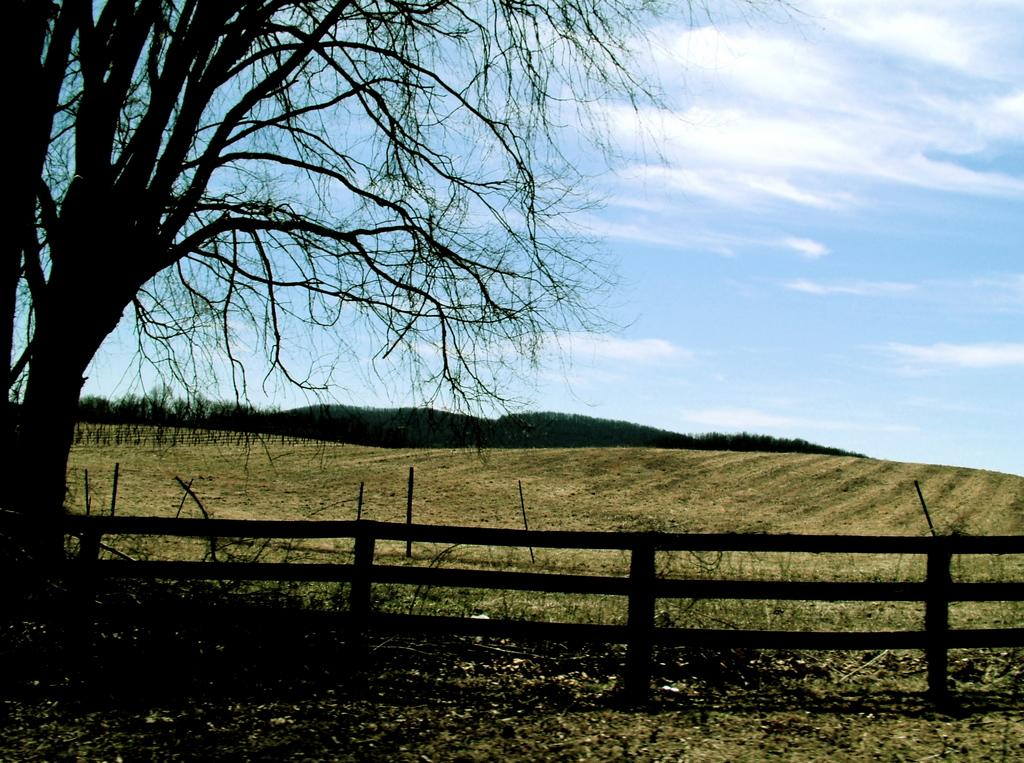What is the setting of the image? The image has an outside view. What can be seen in the foreground of the image? There is a fencing in the foreground. What type of vegetation is on the left side of the image? There is a tree on the left side of the image. What is visible in the background of the image? The sky is visible in the background. What type of paper is being crushed by the tree in the image? There is no paper present in the image, nor is there any indication of a tree crushing anything. 